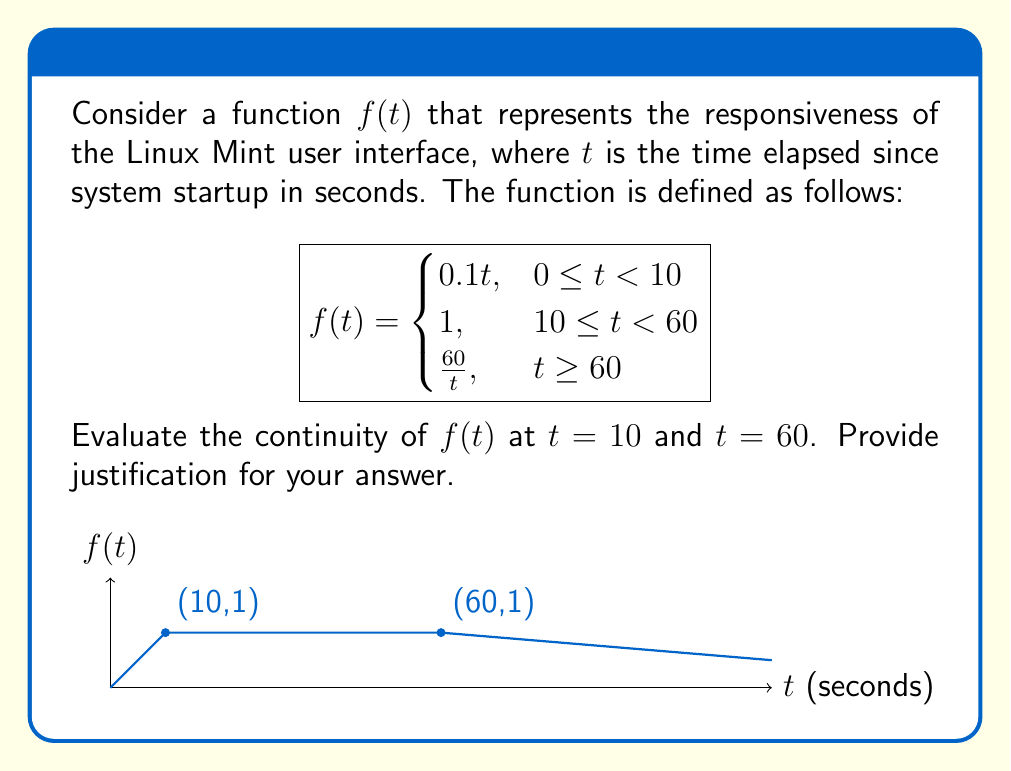Give your solution to this math problem. To evaluate the continuity of $f(t)$ at $t = 10$ and $t = 60$, we need to check if the function satisfies the three conditions for continuity at these points:

1. The function is defined at the point.
2. The limit of the function exists as we approach the point from both sides.
3. The limit equals the function value at that point.

For $t = 10$:

1. $f(10)$ is defined and equals 1.
2. Left-hand limit: 
   $\lim_{t \to 10^-} f(t) = \lim_{t \to 10^-} 0.1t = 1$
   Right-hand limit: 
   $\lim_{t \to 10^+} f(t) = 1$
3. $\lim_{t \to 10} f(t) = f(10) = 1$

All three conditions are satisfied, so $f(t)$ is continuous at $t = 10$.

For $t = 60$:

1. $f(60)$ is defined and equals 1.
2. Left-hand limit: 
   $\lim_{t \to 60^-} f(t) = 1$
   Right-hand limit: 
   $\lim_{t \to 60^+} f(t) = \lim_{t \to 60^+} \frac{60}{t} = 1$
3. $\lim_{t \to 60} f(t) = f(60) = 1$

All three conditions are satisfied, so $f(t)$ is continuous at $t = 60$.

Therefore, the function $f(t)$ is continuous at both $t = 10$ and $t = 60$, ensuring a smooth transition in UI responsiveness across different time intervals since system startup.
Answer: $f(t)$ is continuous at both $t = 10$ and $t = 60$. 